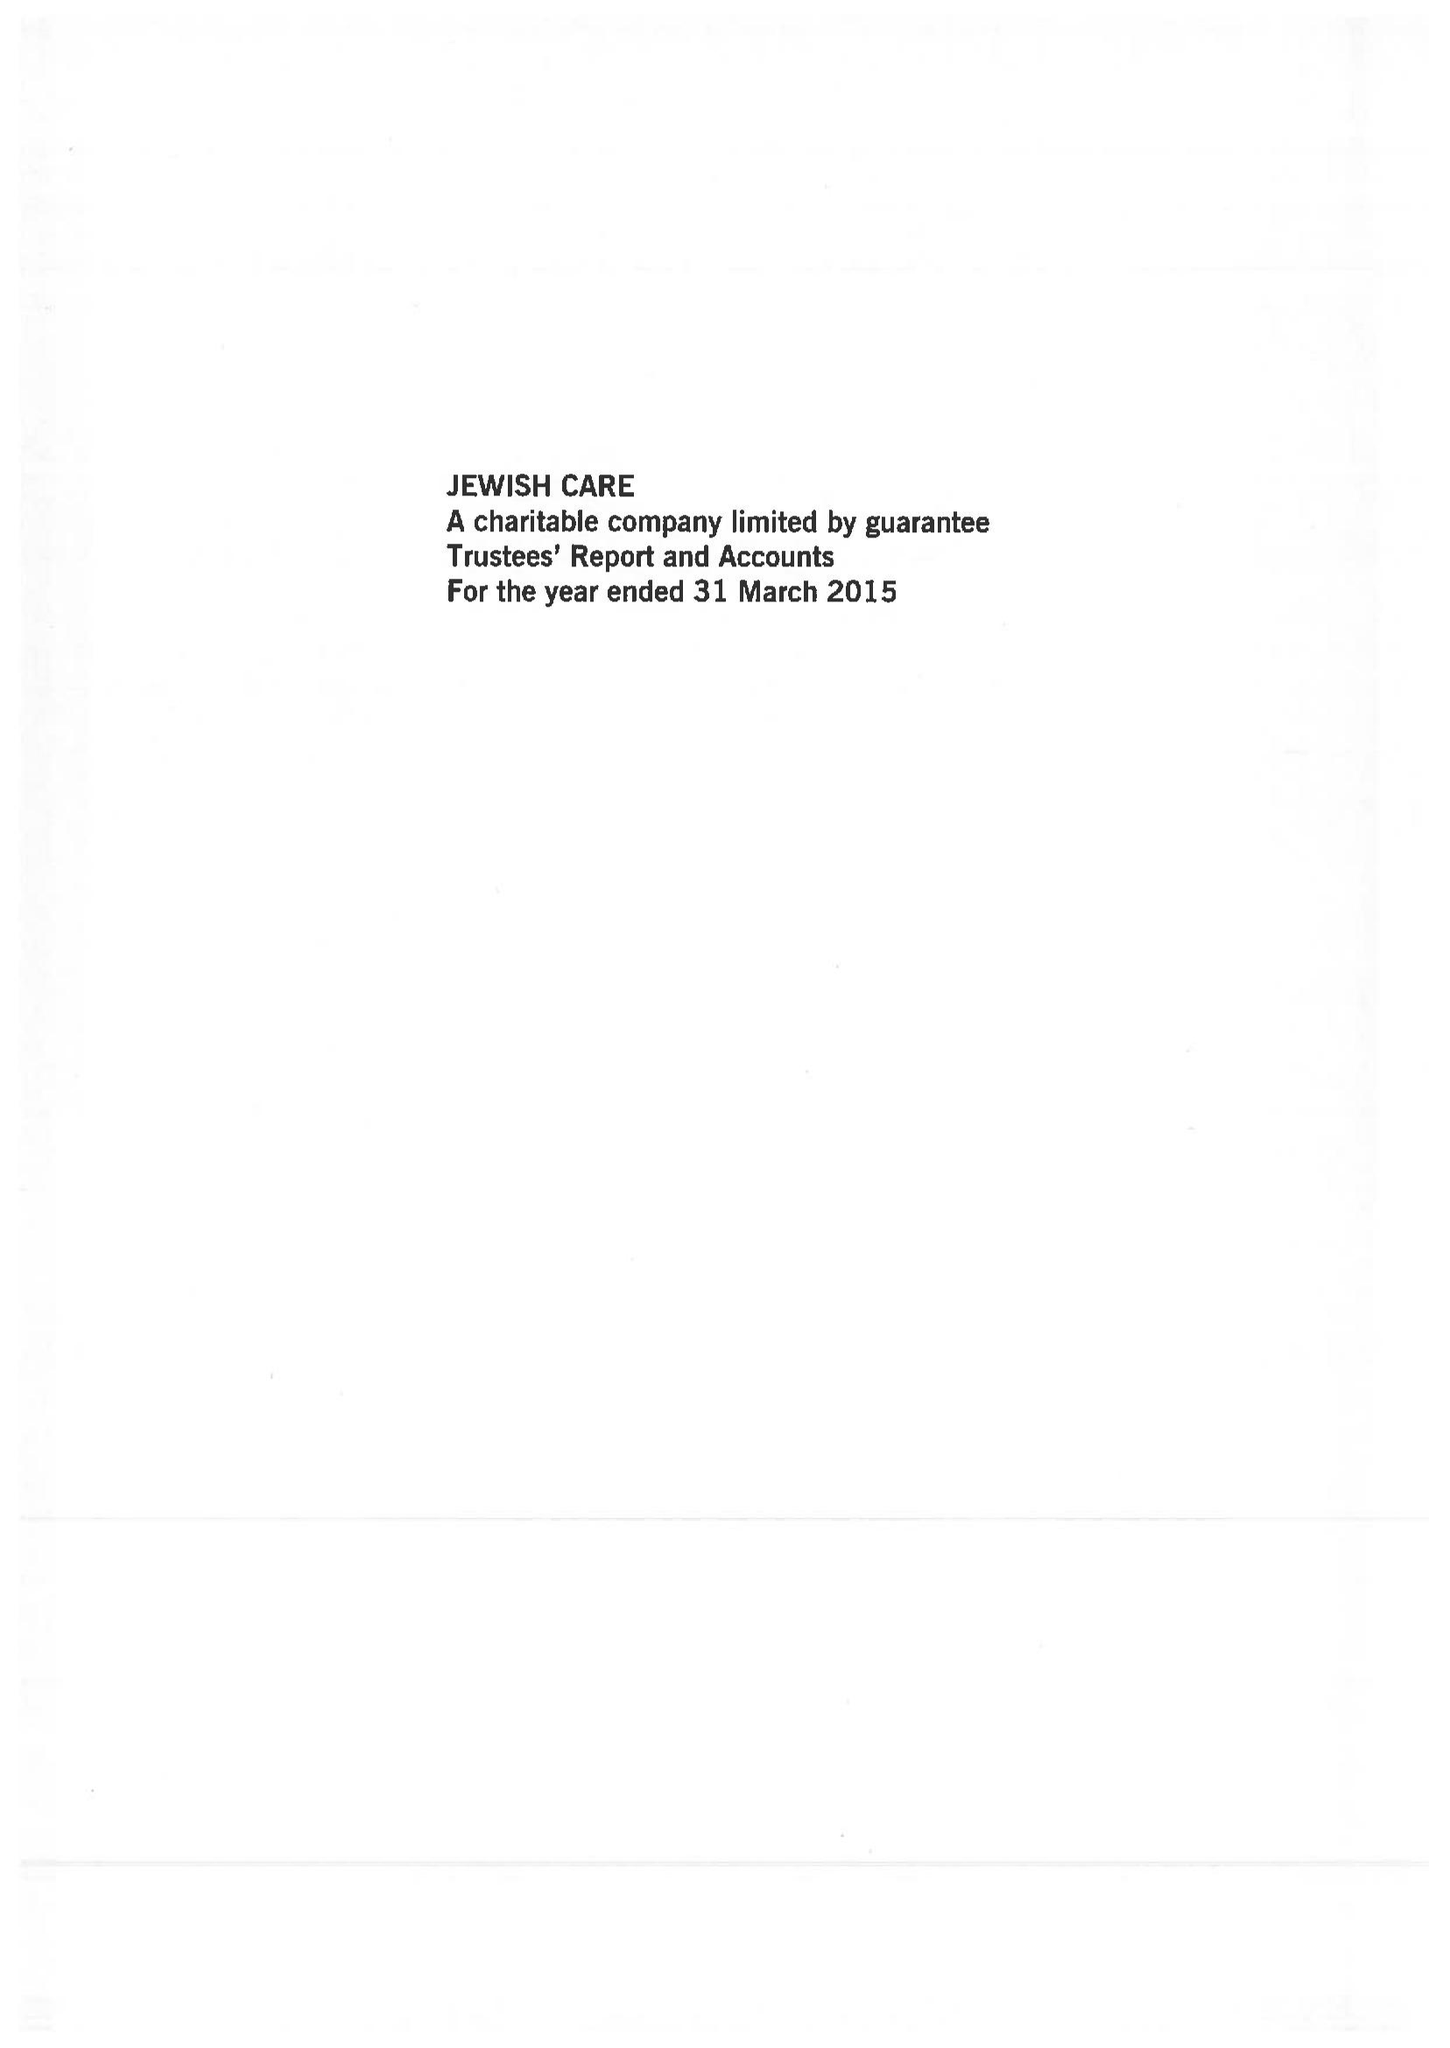What is the value for the address__postcode?
Answer the question using a single word or phrase. NW11 9DQ 